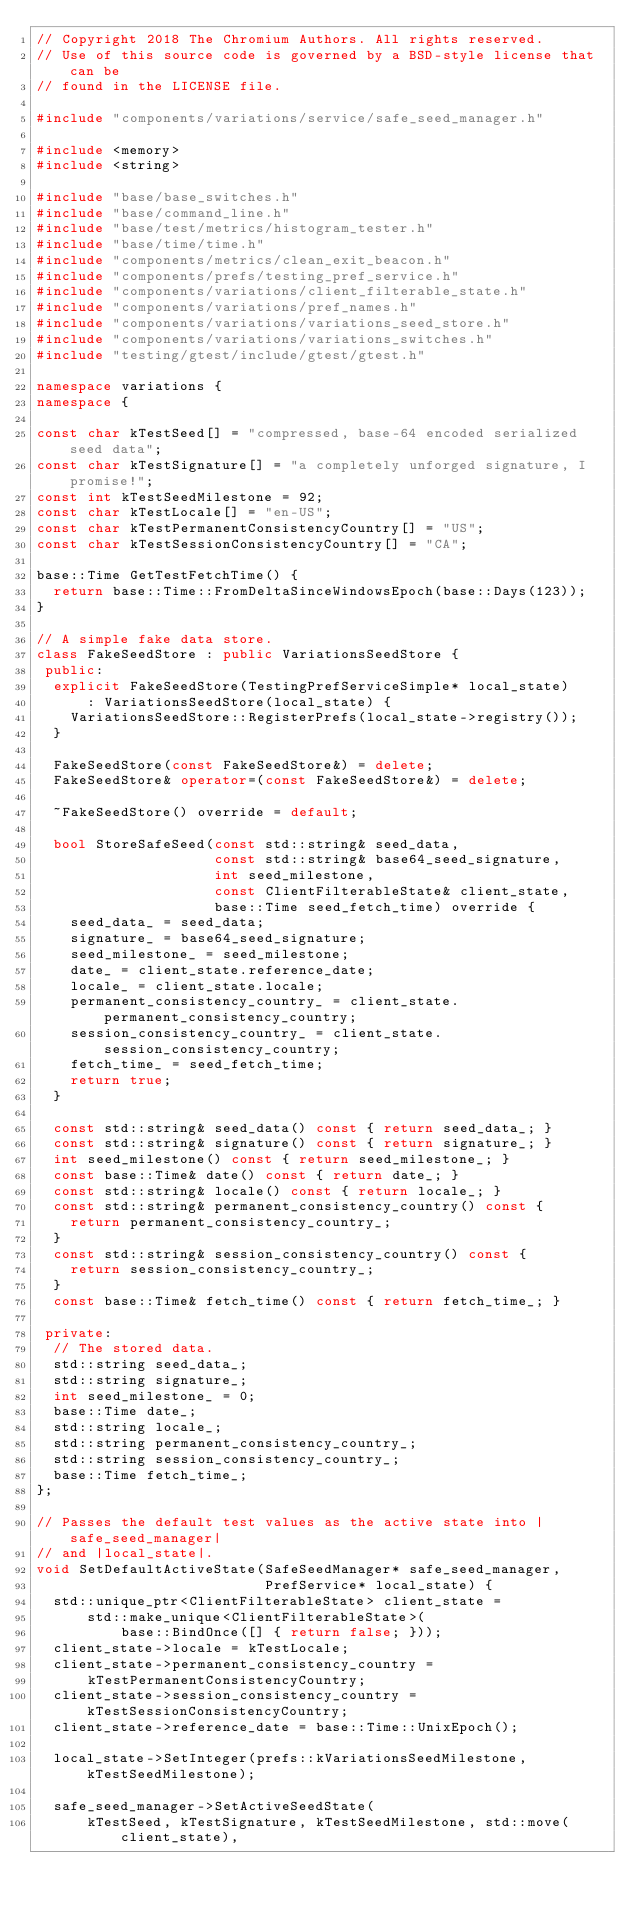Convert code to text. <code><loc_0><loc_0><loc_500><loc_500><_C++_>// Copyright 2018 The Chromium Authors. All rights reserved.
// Use of this source code is governed by a BSD-style license that can be
// found in the LICENSE file.

#include "components/variations/service/safe_seed_manager.h"

#include <memory>
#include <string>

#include "base/base_switches.h"
#include "base/command_line.h"
#include "base/test/metrics/histogram_tester.h"
#include "base/time/time.h"
#include "components/metrics/clean_exit_beacon.h"
#include "components/prefs/testing_pref_service.h"
#include "components/variations/client_filterable_state.h"
#include "components/variations/pref_names.h"
#include "components/variations/variations_seed_store.h"
#include "components/variations/variations_switches.h"
#include "testing/gtest/include/gtest/gtest.h"

namespace variations {
namespace {

const char kTestSeed[] = "compressed, base-64 encoded serialized seed data";
const char kTestSignature[] = "a completely unforged signature, I promise!";
const int kTestSeedMilestone = 92;
const char kTestLocale[] = "en-US";
const char kTestPermanentConsistencyCountry[] = "US";
const char kTestSessionConsistencyCountry[] = "CA";

base::Time GetTestFetchTime() {
  return base::Time::FromDeltaSinceWindowsEpoch(base::Days(123));
}

// A simple fake data store.
class FakeSeedStore : public VariationsSeedStore {
 public:
  explicit FakeSeedStore(TestingPrefServiceSimple* local_state)
      : VariationsSeedStore(local_state) {
    VariationsSeedStore::RegisterPrefs(local_state->registry());
  }

  FakeSeedStore(const FakeSeedStore&) = delete;
  FakeSeedStore& operator=(const FakeSeedStore&) = delete;

  ~FakeSeedStore() override = default;

  bool StoreSafeSeed(const std::string& seed_data,
                     const std::string& base64_seed_signature,
                     int seed_milestone,
                     const ClientFilterableState& client_state,
                     base::Time seed_fetch_time) override {
    seed_data_ = seed_data;
    signature_ = base64_seed_signature;
    seed_milestone_ = seed_milestone;
    date_ = client_state.reference_date;
    locale_ = client_state.locale;
    permanent_consistency_country_ = client_state.permanent_consistency_country;
    session_consistency_country_ = client_state.session_consistency_country;
    fetch_time_ = seed_fetch_time;
    return true;
  }

  const std::string& seed_data() const { return seed_data_; }
  const std::string& signature() const { return signature_; }
  int seed_milestone() const { return seed_milestone_; }
  const base::Time& date() const { return date_; }
  const std::string& locale() const { return locale_; }
  const std::string& permanent_consistency_country() const {
    return permanent_consistency_country_;
  }
  const std::string& session_consistency_country() const {
    return session_consistency_country_;
  }
  const base::Time& fetch_time() const { return fetch_time_; }

 private:
  // The stored data.
  std::string seed_data_;
  std::string signature_;
  int seed_milestone_ = 0;
  base::Time date_;
  std::string locale_;
  std::string permanent_consistency_country_;
  std::string session_consistency_country_;
  base::Time fetch_time_;
};

// Passes the default test values as the active state into |safe_seed_manager|
// and |local_state|.
void SetDefaultActiveState(SafeSeedManager* safe_seed_manager,
                           PrefService* local_state) {
  std::unique_ptr<ClientFilterableState> client_state =
      std::make_unique<ClientFilterableState>(
          base::BindOnce([] { return false; }));
  client_state->locale = kTestLocale;
  client_state->permanent_consistency_country =
      kTestPermanentConsistencyCountry;
  client_state->session_consistency_country = kTestSessionConsistencyCountry;
  client_state->reference_date = base::Time::UnixEpoch();

  local_state->SetInteger(prefs::kVariationsSeedMilestone, kTestSeedMilestone);

  safe_seed_manager->SetActiveSeedState(
      kTestSeed, kTestSignature, kTestSeedMilestone, std::move(client_state),</code> 